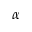Convert formula to latex. <formula><loc_0><loc_0><loc_500><loc_500>\alpha</formula> 